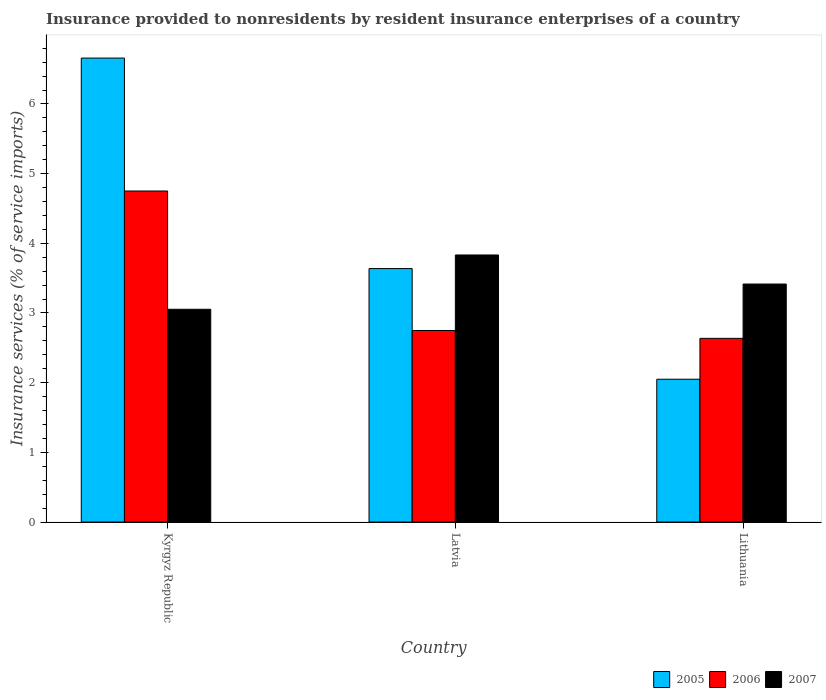How many different coloured bars are there?
Your answer should be very brief. 3. Are the number of bars on each tick of the X-axis equal?
Offer a terse response. Yes. How many bars are there on the 1st tick from the right?
Ensure brevity in your answer.  3. What is the label of the 1st group of bars from the left?
Your answer should be compact. Kyrgyz Republic. What is the insurance provided to nonresidents in 2007 in Latvia?
Your response must be concise. 3.83. Across all countries, what is the maximum insurance provided to nonresidents in 2006?
Keep it short and to the point. 4.75. Across all countries, what is the minimum insurance provided to nonresidents in 2005?
Make the answer very short. 2.05. In which country was the insurance provided to nonresidents in 2005 maximum?
Provide a succinct answer. Kyrgyz Republic. In which country was the insurance provided to nonresidents in 2006 minimum?
Ensure brevity in your answer.  Lithuania. What is the total insurance provided to nonresidents in 2006 in the graph?
Your answer should be very brief. 10.14. What is the difference between the insurance provided to nonresidents in 2006 in Latvia and that in Lithuania?
Make the answer very short. 0.11. What is the difference between the insurance provided to nonresidents in 2007 in Lithuania and the insurance provided to nonresidents in 2005 in Latvia?
Provide a short and direct response. -0.22. What is the average insurance provided to nonresidents in 2006 per country?
Your response must be concise. 3.38. What is the difference between the insurance provided to nonresidents of/in 2005 and insurance provided to nonresidents of/in 2007 in Latvia?
Keep it short and to the point. -0.2. In how many countries, is the insurance provided to nonresidents in 2007 greater than 2.2 %?
Your response must be concise. 3. What is the ratio of the insurance provided to nonresidents in 2006 in Latvia to that in Lithuania?
Offer a terse response. 1.04. Is the difference between the insurance provided to nonresidents in 2005 in Kyrgyz Republic and Lithuania greater than the difference between the insurance provided to nonresidents in 2007 in Kyrgyz Republic and Lithuania?
Provide a short and direct response. Yes. What is the difference between the highest and the second highest insurance provided to nonresidents in 2006?
Offer a terse response. 0.11. What is the difference between the highest and the lowest insurance provided to nonresidents in 2006?
Your answer should be very brief. 2.11. In how many countries, is the insurance provided to nonresidents in 2006 greater than the average insurance provided to nonresidents in 2006 taken over all countries?
Provide a short and direct response. 1. Is the sum of the insurance provided to nonresidents in 2007 in Kyrgyz Republic and Lithuania greater than the maximum insurance provided to nonresidents in 2006 across all countries?
Ensure brevity in your answer.  Yes. What does the 2nd bar from the right in Kyrgyz Republic represents?
Ensure brevity in your answer.  2006. Is it the case that in every country, the sum of the insurance provided to nonresidents in 2006 and insurance provided to nonresidents in 2007 is greater than the insurance provided to nonresidents in 2005?
Ensure brevity in your answer.  Yes. Are all the bars in the graph horizontal?
Make the answer very short. No. What is the difference between two consecutive major ticks on the Y-axis?
Ensure brevity in your answer.  1. Are the values on the major ticks of Y-axis written in scientific E-notation?
Make the answer very short. No. Does the graph contain grids?
Your response must be concise. No. How many legend labels are there?
Your answer should be very brief. 3. How are the legend labels stacked?
Provide a short and direct response. Horizontal. What is the title of the graph?
Your response must be concise. Insurance provided to nonresidents by resident insurance enterprises of a country. What is the label or title of the Y-axis?
Provide a succinct answer. Insurance services (% of service imports). What is the Insurance services (% of service imports) of 2005 in Kyrgyz Republic?
Your answer should be compact. 6.66. What is the Insurance services (% of service imports) in 2006 in Kyrgyz Republic?
Provide a short and direct response. 4.75. What is the Insurance services (% of service imports) in 2007 in Kyrgyz Republic?
Offer a very short reply. 3.05. What is the Insurance services (% of service imports) of 2005 in Latvia?
Your answer should be very brief. 3.64. What is the Insurance services (% of service imports) in 2006 in Latvia?
Make the answer very short. 2.75. What is the Insurance services (% of service imports) in 2007 in Latvia?
Your response must be concise. 3.83. What is the Insurance services (% of service imports) in 2005 in Lithuania?
Your answer should be very brief. 2.05. What is the Insurance services (% of service imports) of 2006 in Lithuania?
Your answer should be very brief. 2.64. What is the Insurance services (% of service imports) of 2007 in Lithuania?
Offer a terse response. 3.42. Across all countries, what is the maximum Insurance services (% of service imports) of 2005?
Provide a short and direct response. 6.66. Across all countries, what is the maximum Insurance services (% of service imports) in 2006?
Ensure brevity in your answer.  4.75. Across all countries, what is the maximum Insurance services (% of service imports) in 2007?
Keep it short and to the point. 3.83. Across all countries, what is the minimum Insurance services (% of service imports) of 2005?
Offer a very short reply. 2.05. Across all countries, what is the minimum Insurance services (% of service imports) in 2006?
Keep it short and to the point. 2.64. Across all countries, what is the minimum Insurance services (% of service imports) in 2007?
Your answer should be very brief. 3.05. What is the total Insurance services (% of service imports) in 2005 in the graph?
Offer a terse response. 12.35. What is the total Insurance services (% of service imports) of 2006 in the graph?
Give a very brief answer. 10.14. What is the total Insurance services (% of service imports) in 2007 in the graph?
Provide a succinct answer. 10.3. What is the difference between the Insurance services (% of service imports) in 2005 in Kyrgyz Republic and that in Latvia?
Provide a short and direct response. 3.02. What is the difference between the Insurance services (% of service imports) in 2006 in Kyrgyz Republic and that in Latvia?
Make the answer very short. 2. What is the difference between the Insurance services (% of service imports) in 2007 in Kyrgyz Republic and that in Latvia?
Give a very brief answer. -0.78. What is the difference between the Insurance services (% of service imports) of 2005 in Kyrgyz Republic and that in Lithuania?
Your answer should be very brief. 4.61. What is the difference between the Insurance services (% of service imports) of 2006 in Kyrgyz Republic and that in Lithuania?
Keep it short and to the point. 2.11. What is the difference between the Insurance services (% of service imports) in 2007 in Kyrgyz Republic and that in Lithuania?
Your answer should be compact. -0.36. What is the difference between the Insurance services (% of service imports) in 2005 in Latvia and that in Lithuania?
Your answer should be compact. 1.59. What is the difference between the Insurance services (% of service imports) of 2006 in Latvia and that in Lithuania?
Keep it short and to the point. 0.11. What is the difference between the Insurance services (% of service imports) of 2007 in Latvia and that in Lithuania?
Your answer should be compact. 0.42. What is the difference between the Insurance services (% of service imports) of 2005 in Kyrgyz Republic and the Insurance services (% of service imports) of 2006 in Latvia?
Give a very brief answer. 3.91. What is the difference between the Insurance services (% of service imports) of 2005 in Kyrgyz Republic and the Insurance services (% of service imports) of 2007 in Latvia?
Ensure brevity in your answer.  2.83. What is the difference between the Insurance services (% of service imports) of 2006 in Kyrgyz Republic and the Insurance services (% of service imports) of 2007 in Latvia?
Provide a succinct answer. 0.92. What is the difference between the Insurance services (% of service imports) of 2005 in Kyrgyz Republic and the Insurance services (% of service imports) of 2006 in Lithuania?
Offer a terse response. 4.02. What is the difference between the Insurance services (% of service imports) of 2005 in Kyrgyz Republic and the Insurance services (% of service imports) of 2007 in Lithuania?
Your answer should be very brief. 3.24. What is the difference between the Insurance services (% of service imports) of 2006 in Kyrgyz Republic and the Insurance services (% of service imports) of 2007 in Lithuania?
Offer a terse response. 1.34. What is the difference between the Insurance services (% of service imports) of 2005 in Latvia and the Insurance services (% of service imports) of 2007 in Lithuania?
Your answer should be compact. 0.22. What is the difference between the Insurance services (% of service imports) in 2006 in Latvia and the Insurance services (% of service imports) in 2007 in Lithuania?
Your answer should be very brief. -0.67. What is the average Insurance services (% of service imports) of 2005 per country?
Offer a terse response. 4.12. What is the average Insurance services (% of service imports) of 2006 per country?
Provide a short and direct response. 3.38. What is the average Insurance services (% of service imports) in 2007 per country?
Offer a very short reply. 3.43. What is the difference between the Insurance services (% of service imports) in 2005 and Insurance services (% of service imports) in 2006 in Kyrgyz Republic?
Your answer should be compact. 1.91. What is the difference between the Insurance services (% of service imports) of 2005 and Insurance services (% of service imports) of 2007 in Kyrgyz Republic?
Your response must be concise. 3.61. What is the difference between the Insurance services (% of service imports) in 2006 and Insurance services (% of service imports) in 2007 in Kyrgyz Republic?
Provide a succinct answer. 1.7. What is the difference between the Insurance services (% of service imports) in 2005 and Insurance services (% of service imports) in 2006 in Latvia?
Provide a succinct answer. 0.89. What is the difference between the Insurance services (% of service imports) in 2005 and Insurance services (% of service imports) in 2007 in Latvia?
Offer a terse response. -0.2. What is the difference between the Insurance services (% of service imports) of 2006 and Insurance services (% of service imports) of 2007 in Latvia?
Keep it short and to the point. -1.08. What is the difference between the Insurance services (% of service imports) in 2005 and Insurance services (% of service imports) in 2006 in Lithuania?
Offer a very short reply. -0.59. What is the difference between the Insurance services (% of service imports) in 2005 and Insurance services (% of service imports) in 2007 in Lithuania?
Your answer should be very brief. -1.37. What is the difference between the Insurance services (% of service imports) of 2006 and Insurance services (% of service imports) of 2007 in Lithuania?
Offer a terse response. -0.78. What is the ratio of the Insurance services (% of service imports) of 2005 in Kyrgyz Republic to that in Latvia?
Your answer should be compact. 1.83. What is the ratio of the Insurance services (% of service imports) of 2006 in Kyrgyz Republic to that in Latvia?
Offer a very short reply. 1.73. What is the ratio of the Insurance services (% of service imports) of 2007 in Kyrgyz Republic to that in Latvia?
Make the answer very short. 0.8. What is the ratio of the Insurance services (% of service imports) in 2005 in Kyrgyz Republic to that in Lithuania?
Your response must be concise. 3.25. What is the ratio of the Insurance services (% of service imports) of 2006 in Kyrgyz Republic to that in Lithuania?
Keep it short and to the point. 1.8. What is the ratio of the Insurance services (% of service imports) of 2007 in Kyrgyz Republic to that in Lithuania?
Your answer should be very brief. 0.89. What is the ratio of the Insurance services (% of service imports) of 2005 in Latvia to that in Lithuania?
Offer a terse response. 1.77. What is the ratio of the Insurance services (% of service imports) in 2006 in Latvia to that in Lithuania?
Your answer should be compact. 1.04. What is the ratio of the Insurance services (% of service imports) in 2007 in Latvia to that in Lithuania?
Offer a terse response. 1.12. What is the difference between the highest and the second highest Insurance services (% of service imports) in 2005?
Your answer should be compact. 3.02. What is the difference between the highest and the second highest Insurance services (% of service imports) in 2006?
Provide a short and direct response. 2. What is the difference between the highest and the second highest Insurance services (% of service imports) of 2007?
Ensure brevity in your answer.  0.42. What is the difference between the highest and the lowest Insurance services (% of service imports) in 2005?
Offer a very short reply. 4.61. What is the difference between the highest and the lowest Insurance services (% of service imports) in 2006?
Your response must be concise. 2.11. What is the difference between the highest and the lowest Insurance services (% of service imports) in 2007?
Keep it short and to the point. 0.78. 